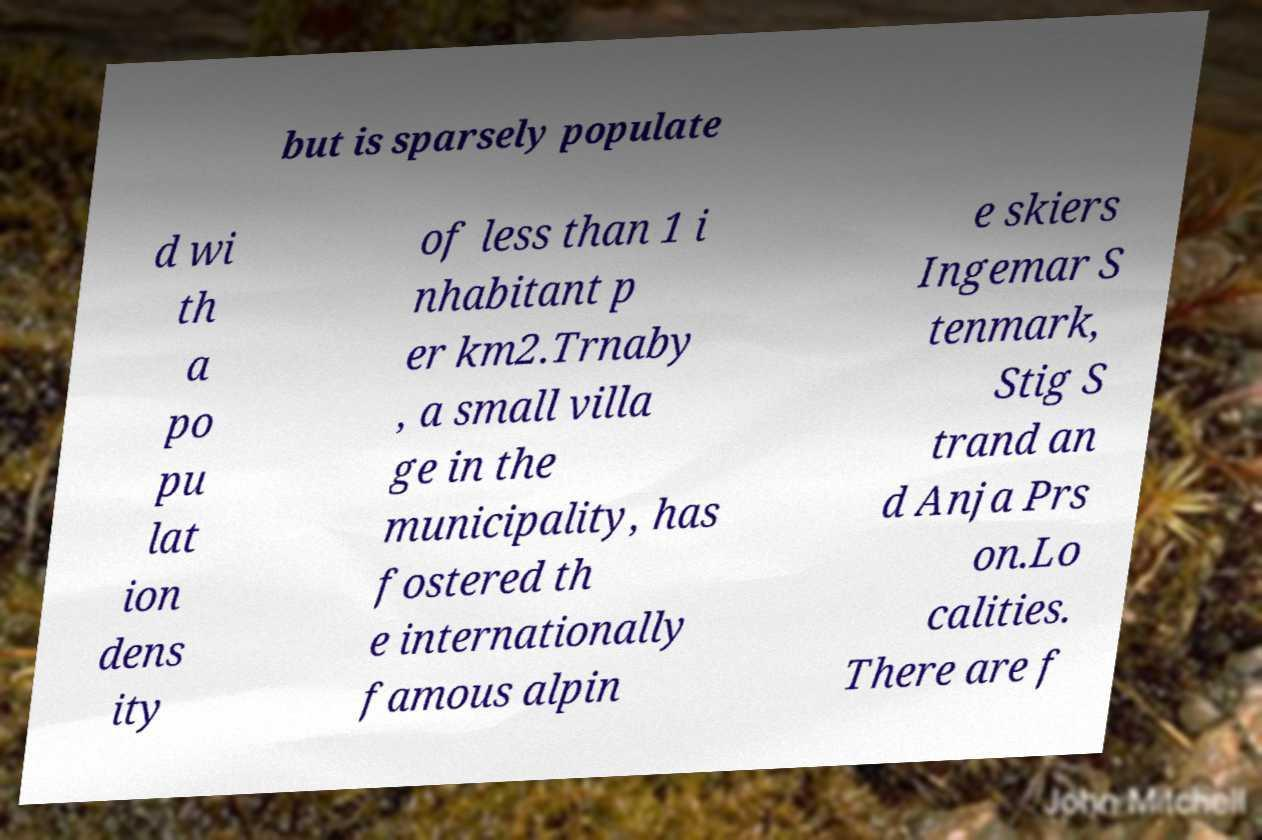Could you extract and type out the text from this image? but is sparsely populate d wi th a po pu lat ion dens ity of less than 1 i nhabitant p er km2.Trnaby , a small villa ge in the municipality, has fostered th e internationally famous alpin e skiers Ingemar S tenmark, Stig S trand an d Anja Prs on.Lo calities. There are f 